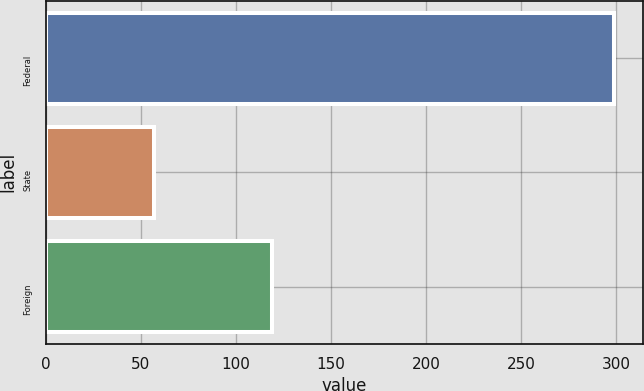<chart> <loc_0><loc_0><loc_500><loc_500><bar_chart><fcel>Federal<fcel>State<fcel>Foreign<nl><fcel>299<fcel>57<fcel>119<nl></chart> 